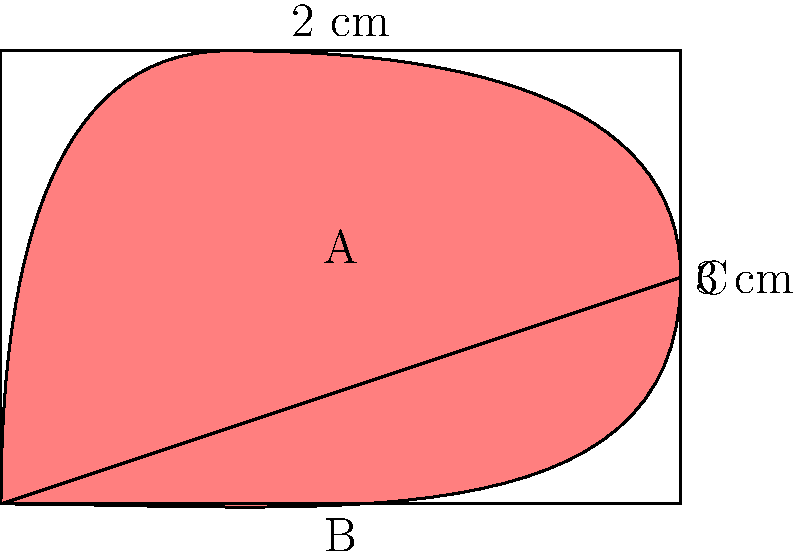As a dermatologist, you're assessing an irregular skin lesion. To approximate its area, you decide to use a geometric approach. The lesion can be enclosed within a rectangle measuring 3 cm by 2 cm, as shown in the diagram. The lower edge of the lesion can be approximated by a straight line from point B to C. If the area of triangle ABC is 1.5 cm², what is the approximate area of the skin lesion in cm²? Let's approach this step-by-step:

1) First, we need to calculate the area of the rectangle:
   Area of rectangle = length × width
   $A_{rectangle} = 3 \text{ cm} \times 2 \text{ cm} = 6 \text{ cm}^2$

2) Now, we know the area of triangle ABC:
   $A_{triangle} = 1.5 \text{ cm}^2$

3) The approximate area of the lesion can be found by subtracting the area of the triangle from the area of the rectangle:
   $A_{lesion} = A_{rectangle} - A_{triangle}$

4) Substituting the values:
   $A_{lesion} = 6 \text{ cm}^2 - 1.5 \text{ cm}^2 = 4.5 \text{ cm}^2$

Therefore, the approximate area of the skin lesion is 4.5 cm².

This geometric approximation method is useful in dermatology for quickly estimating the size of irregular lesions, which can be important for monitoring changes over time or assessing the efficacy of treatments.
Answer: 4.5 cm² 